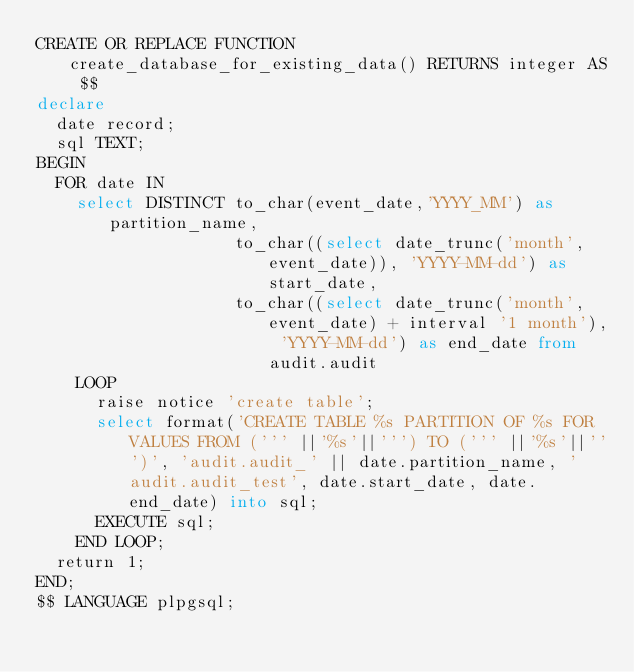Convert code to text. <code><loc_0><loc_0><loc_500><loc_500><_SQL_>CREATE OR REPLACE FUNCTION create_database_for_existing_data() RETURNS integer AS $$
declare
  date record;
  sql TEXT;
BEGIN
  FOR date IN
    select DISTINCT to_char(event_date,'YYYY_MM') as partition_name,
                    to_char((select date_trunc('month', event_date)), 'YYYY-MM-dd') as start_date,
                    to_char((select date_trunc('month', event_date) + interval '1 month'), 'YYYY-MM-dd') as end_date from audit.audit
    LOOP
      raise notice 'create table';
      select format('CREATE TABLE %s PARTITION OF %s FOR VALUES FROM (''' ||'%s'||''') TO (''' ||'%s'||''')', 'audit.audit_' || date.partition_name, 'audit.audit_test', date.start_date, date.end_date) into sql;
      EXECUTE sql;
    END LOOP;
  return 1;
END;
$$ LANGUAGE plpgsql;</code> 